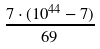<formula> <loc_0><loc_0><loc_500><loc_500>\frac { 7 \cdot ( 1 0 ^ { 4 4 } - 7 ) } { 6 9 }</formula> 